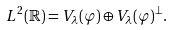<formula> <loc_0><loc_0><loc_500><loc_500>L ^ { 2 } ( \mathbb { R } ) = V _ { \lambda } ( \varphi ) \oplus V _ { \lambda } ( \varphi ) ^ { \perp } .</formula> 